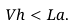Convert formula to latex. <formula><loc_0><loc_0><loc_500><loc_500>V h < L a .</formula> 